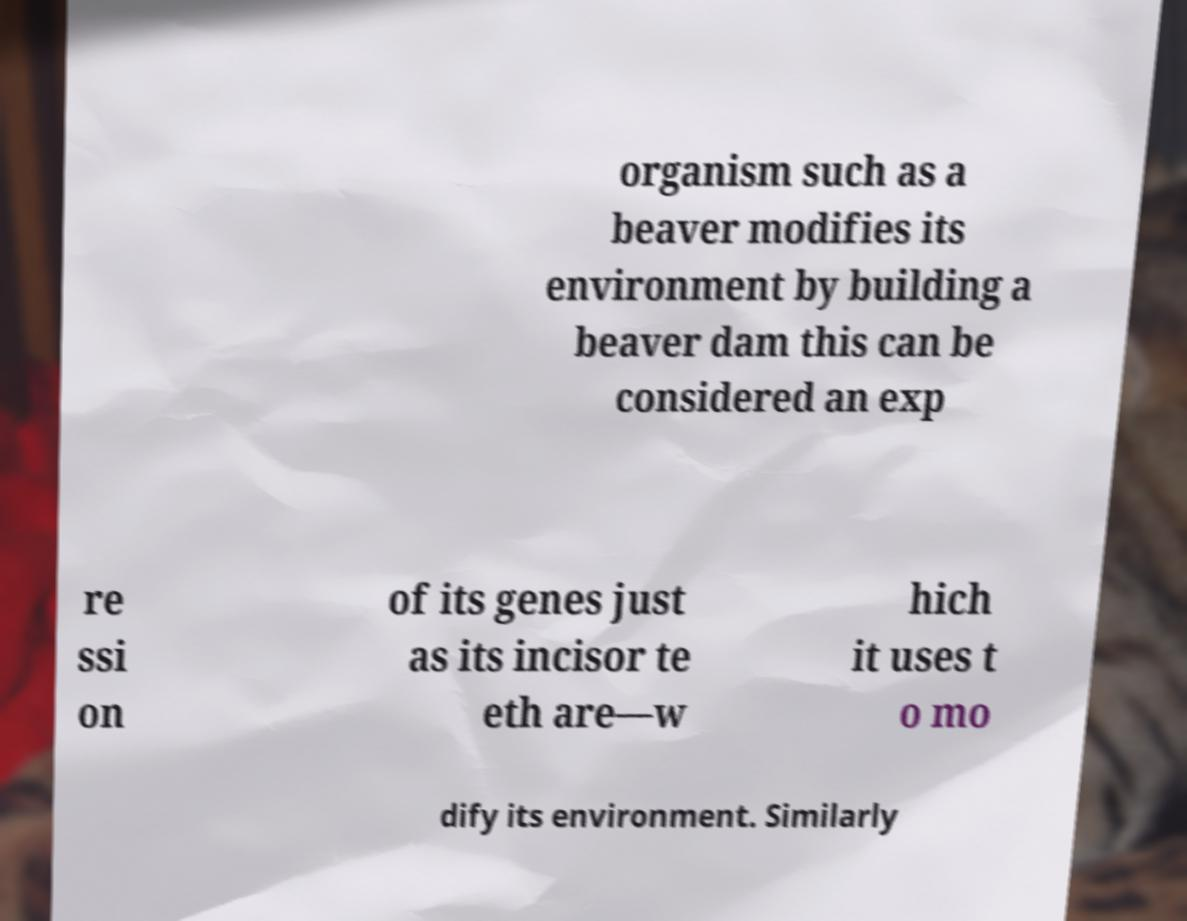Could you extract and type out the text from this image? organism such as a beaver modifies its environment by building a beaver dam this can be considered an exp re ssi on of its genes just as its incisor te eth are—w hich it uses t o mo dify its environment. Similarly 